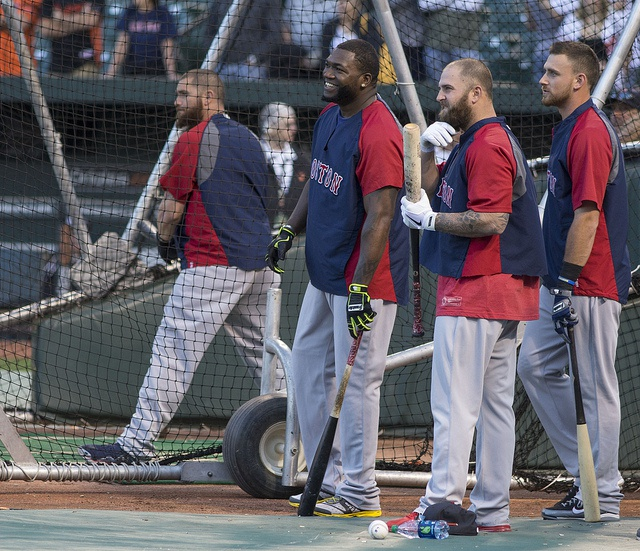Describe the objects in this image and their specific colors. I can see people in gray, darkgray, navy, and lightgray tones, people in gray, navy, black, and darkgray tones, people in gray, darkgray, black, and navy tones, people in gray, navy, darkgray, and black tones, and people in gray, black, and navy tones in this image. 